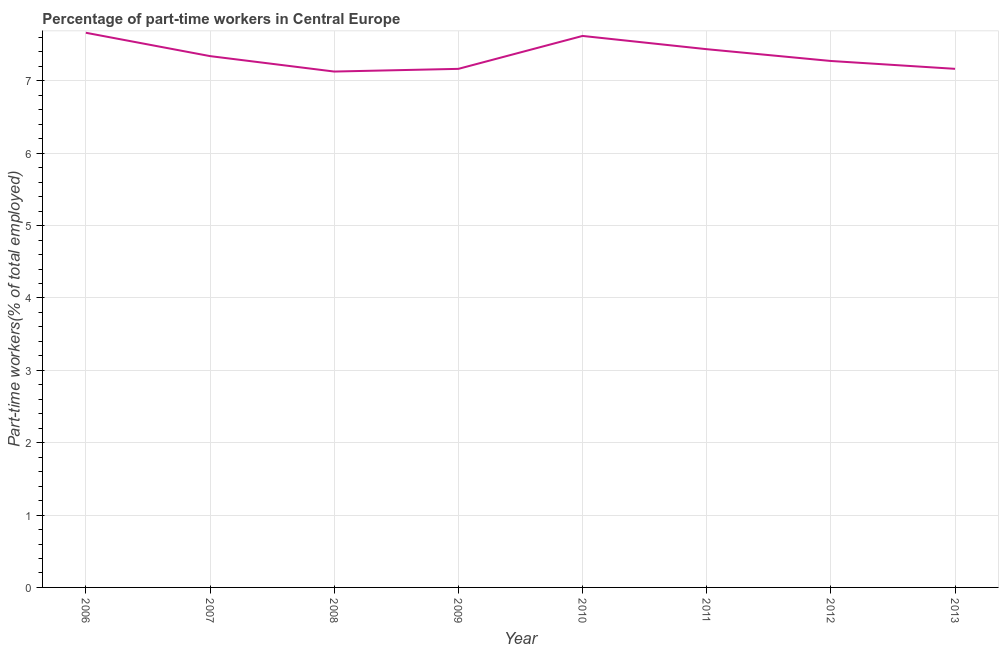What is the percentage of part-time workers in 2010?
Your response must be concise. 7.62. Across all years, what is the maximum percentage of part-time workers?
Provide a short and direct response. 7.67. Across all years, what is the minimum percentage of part-time workers?
Keep it short and to the point. 7.13. What is the sum of the percentage of part-time workers?
Keep it short and to the point. 58.81. What is the difference between the percentage of part-time workers in 2009 and 2013?
Provide a short and direct response. -0. What is the average percentage of part-time workers per year?
Your response must be concise. 7.35. What is the median percentage of part-time workers?
Keep it short and to the point. 7.31. In how many years, is the percentage of part-time workers greater than 1.2 %?
Your answer should be very brief. 8. Do a majority of the years between 2012 and 2007 (inclusive) have percentage of part-time workers greater than 2.4 %?
Your answer should be compact. Yes. What is the ratio of the percentage of part-time workers in 2007 to that in 2011?
Offer a very short reply. 0.99. Is the difference between the percentage of part-time workers in 2006 and 2013 greater than the difference between any two years?
Make the answer very short. No. What is the difference between the highest and the second highest percentage of part-time workers?
Offer a very short reply. 0.04. What is the difference between the highest and the lowest percentage of part-time workers?
Ensure brevity in your answer.  0.54. In how many years, is the percentage of part-time workers greater than the average percentage of part-time workers taken over all years?
Your response must be concise. 3. Does the percentage of part-time workers monotonically increase over the years?
Ensure brevity in your answer.  No. What is the difference between two consecutive major ticks on the Y-axis?
Make the answer very short. 1. Are the values on the major ticks of Y-axis written in scientific E-notation?
Ensure brevity in your answer.  No. Does the graph contain grids?
Offer a very short reply. Yes. What is the title of the graph?
Give a very brief answer. Percentage of part-time workers in Central Europe. What is the label or title of the X-axis?
Offer a terse response. Year. What is the label or title of the Y-axis?
Provide a short and direct response. Part-time workers(% of total employed). What is the Part-time workers(% of total employed) in 2006?
Give a very brief answer. 7.67. What is the Part-time workers(% of total employed) in 2007?
Your answer should be compact. 7.34. What is the Part-time workers(% of total employed) in 2008?
Offer a very short reply. 7.13. What is the Part-time workers(% of total employed) in 2009?
Make the answer very short. 7.17. What is the Part-time workers(% of total employed) of 2010?
Your answer should be compact. 7.62. What is the Part-time workers(% of total employed) of 2011?
Make the answer very short. 7.44. What is the Part-time workers(% of total employed) in 2012?
Give a very brief answer. 7.28. What is the Part-time workers(% of total employed) in 2013?
Offer a very short reply. 7.17. What is the difference between the Part-time workers(% of total employed) in 2006 and 2007?
Give a very brief answer. 0.32. What is the difference between the Part-time workers(% of total employed) in 2006 and 2008?
Keep it short and to the point. 0.54. What is the difference between the Part-time workers(% of total employed) in 2006 and 2009?
Provide a succinct answer. 0.5. What is the difference between the Part-time workers(% of total employed) in 2006 and 2010?
Your answer should be very brief. 0.04. What is the difference between the Part-time workers(% of total employed) in 2006 and 2011?
Ensure brevity in your answer.  0.23. What is the difference between the Part-time workers(% of total employed) in 2006 and 2012?
Offer a terse response. 0.39. What is the difference between the Part-time workers(% of total employed) in 2006 and 2013?
Provide a short and direct response. 0.5. What is the difference between the Part-time workers(% of total employed) in 2007 and 2008?
Keep it short and to the point. 0.21. What is the difference between the Part-time workers(% of total employed) in 2007 and 2009?
Give a very brief answer. 0.18. What is the difference between the Part-time workers(% of total employed) in 2007 and 2010?
Provide a short and direct response. -0.28. What is the difference between the Part-time workers(% of total employed) in 2007 and 2011?
Your answer should be compact. -0.1. What is the difference between the Part-time workers(% of total employed) in 2007 and 2012?
Provide a succinct answer. 0.07. What is the difference between the Part-time workers(% of total employed) in 2007 and 2013?
Offer a terse response. 0.18. What is the difference between the Part-time workers(% of total employed) in 2008 and 2009?
Provide a short and direct response. -0.04. What is the difference between the Part-time workers(% of total employed) in 2008 and 2010?
Keep it short and to the point. -0.49. What is the difference between the Part-time workers(% of total employed) in 2008 and 2011?
Make the answer very short. -0.31. What is the difference between the Part-time workers(% of total employed) in 2008 and 2012?
Give a very brief answer. -0.15. What is the difference between the Part-time workers(% of total employed) in 2008 and 2013?
Your response must be concise. -0.04. What is the difference between the Part-time workers(% of total employed) in 2009 and 2010?
Offer a terse response. -0.46. What is the difference between the Part-time workers(% of total employed) in 2009 and 2011?
Keep it short and to the point. -0.27. What is the difference between the Part-time workers(% of total employed) in 2009 and 2012?
Give a very brief answer. -0.11. What is the difference between the Part-time workers(% of total employed) in 2009 and 2013?
Provide a succinct answer. -0. What is the difference between the Part-time workers(% of total employed) in 2010 and 2011?
Offer a very short reply. 0.18. What is the difference between the Part-time workers(% of total employed) in 2010 and 2012?
Provide a short and direct response. 0.35. What is the difference between the Part-time workers(% of total employed) in 2010 and 2013?
Offer a very short reply. 0.45. What is the difference between the Part-time workers(% of total employed) in 2011 and 2012?
Keep it short and to the point. 0.16. What is the difference between the Part-time workers(% of total employed) in 2011 and 2013?
Your answer should be very brief. 0.27. What is the difference between the Part-time workers(% of total employed) in 2012 and 2013?
Provide a short and direct response. 0.11. What is the ratio of the Part-time workers(% of total employed) in 2006 to that in 2007?
Give a very brief answer. 1.04. What is the ratio of the Part-time workers(% of total employed) in 2006 to that in 2008?
Give a very brief answer. 1.07. What is the ratio of the Part-time workers(% of total employed) in 2006 to that in 2009?
Offer a terse response. 1.07. What is the ratio of the Part-time workers(% of total employed) in 2006 to that in 2010?
Offer a very short reply. 1.01. What is the ratio of the Part-time workers(% of total employed) in 2006 to that in 2011?
Give a very brief answer. 1.03. What is the ratio of the Part-time workers(% of total employed) in 2006 to that in 2012?
Offer a terse response. 1.05. What is the ratio of the Part-time workers(% of total employed) in 2006 to that in 2013?
Give a very brief answer. 1.07. What is the ratio of the Part-time workers(% of total employed) in 2007 to that in 2009?
Make the answer very short. 1.02. What is the ratio of the Part-time workers(% of total employed) in 2007 to that in 2012?
Your answer should be very brief. 1.01. What is the ratio of the Part-time workers(% of total employed) in 2007 to that in 2013?
Provide a short and direct response. 1.02. What is the ratio of the Part-time workers(% of total employed) in 2008 to that in 2009?
Provide a short and direct response. 0.99. What is the ratio of the Part-time workers(% of total employed) in 2008 to that in 2010?
Provide a short and direct response. 0.94. What is the ratio of the Part-time workers(% of total employed) in 2008 to that in 2011?
Your response must be concise. 0.96. What is the ratio of the Part-time workers(% of total employed) in 2008 to that in 2012?
Offer a terse response. 0.98. What is the ratio of the Part-time workers(% of total employed) in 2009 to that in 2013?
Your answer should be compact. 1. What is the ratio of the Part-time workers(% of total employed) in 2010 to that in 2012?
Give a very brief answer. 1.05. What is the ratio of the Part-time workers(% of total employed) in 2010 to that in 2013?
Ensure brevity in your answer.  1.06. What is the ratio of the Part-time workers(% of total employed) in 2011 to that in 2013?
Provide a short and direct response. 1.04. 